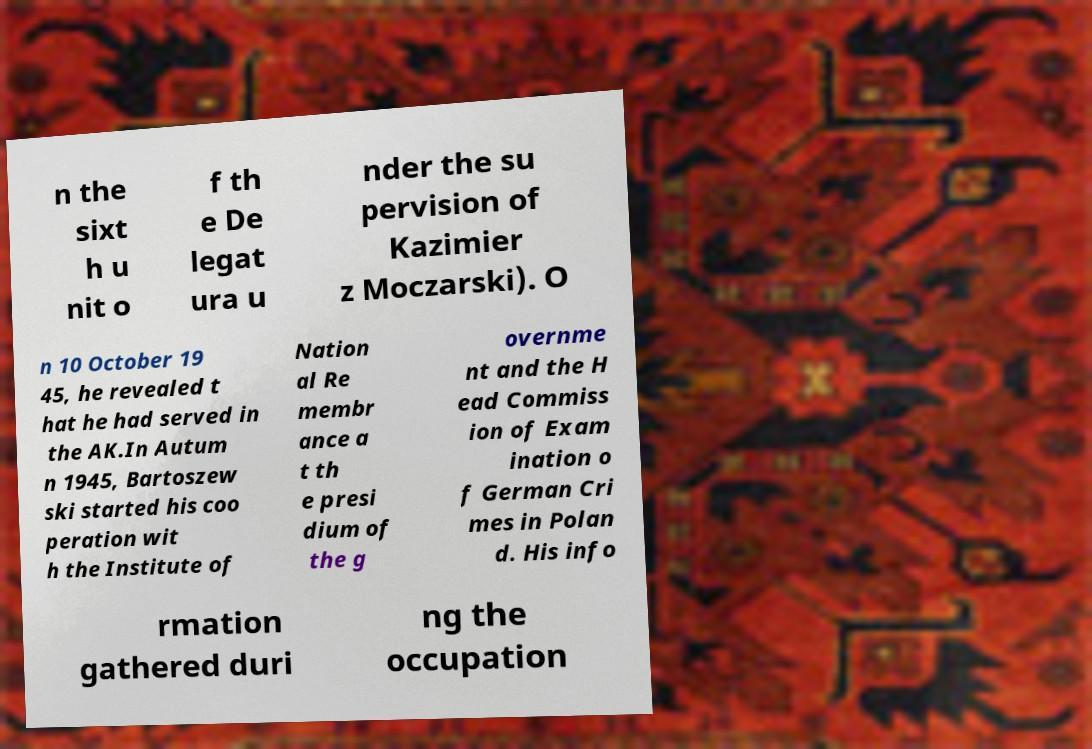For documentation purposes, I need the text within this image transcribed. Could you provide that? n the sixt h u nit o f th e De legat ura u nder the su pervision of Kazimier z Moczarski). O n 10 October 19 45, he revealed t hat he had served in the AK.In Autum n 1945, Bartoszew ski started his coo peration wit h the Institute of Nation al Re membr ance a t th e presi dium of the g overnme nt and the H ead Commiss ion of Exam ination o f German Cri mes in Polan d. His info rmation gathered duri ng the occupation 